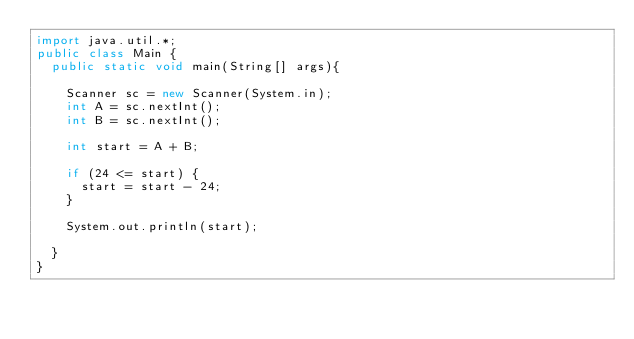Convert code to text. <code><loc_0><loc_0><loc_500><loc_500><_Java_>import java.util.*;
public class Main {
  public static void main(String[] args){

    Scanner sc = new Scanner(System.in);
    int A = sc.nextInt();
    int B = sc.nextInt();

    int start = A + B;

    if (24 <= start) {
      start = start - 24;
    }

    System.out.println(start);

  }
}</code> 